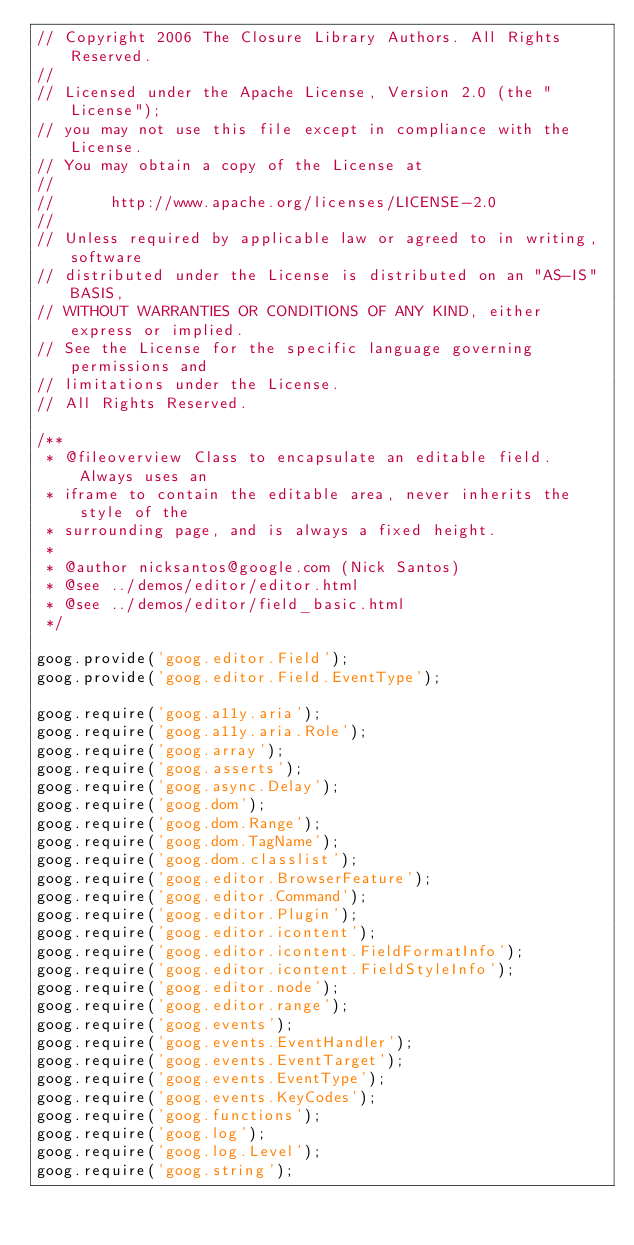Convert code to text. <code><loc_0><loc_0><loc_500><loc_500><_JavaScript_>// Copyright 2006 The Closure Library Authors. All Rights Reserved.
//
// Licensed under the Apache License, Version 2.0 (the "License");
// you may not use this file except in compliance with the License.
// You may obtain a copy of the License at
//
//      http://www.apache.org/licenses/LICENSE-2.0
//
// Unless required by applicable law or agreed to in writing, software
// distributed under the License is distributed on an "AS-IS" BASIS,
// WITHOUT WARRANTIES OR CONDITIONS OF ANY KIND, either express or implied.
// See the License for the specific language governing permissions and
// limitations under the License.
// All Rights Reserved.

/**
 * @fileoverview Class to encapsulate an editable field.  Always uses an
 * iframe to contain the editable area, never inherits the style of the
 * surrounding page, and is always a fixed height.
 *
 * @author nicksantos@google.com (Nick Santos)
 * @see ../demos/editor/editor.html
 * @see ../demos/editor/field_basic.html
 */

goog.provide('goog.editor.Field');
goog.provide('goog.editor.Field.EventType');

goog.require('goog.a11y.aria');
goog.require('goog.a11y.aria.Role');
goog.require('goog.array');
goog.require('goog.asserts');
goog.require('goog.async.Delay');
goog.require('goog.dom');
goog.require('goog.dom.Range');
goog.require('goog.dom.TagName');
goog.require('goog.dom.classlist');
goog.require('goog.editor.BrowserFeature');
goog.require('goog.editor.Command');
goog.require('goog.editor.Plugin');
goog.require('goog.editor.icontent');
goog.require('goog.editor.icontent.FieldFormatInfo');
goog.require('goog.editor.icontent.FieldStyleInfo');
goog.require('goog.editor.node');
goog.require('goog.editor.range');
goog.require('goog.events');
goog.require('goog.events.EventHandler');
goog.require('goog.events.EventTarget');
goog.require('goog.events.EventType');
goog.require('goog.events.KeyCodes');
goog.require('goog.functions');
goog.require('goog.log');
goog.require('goog.log.Level');
goog.require('goog.string');</code> 